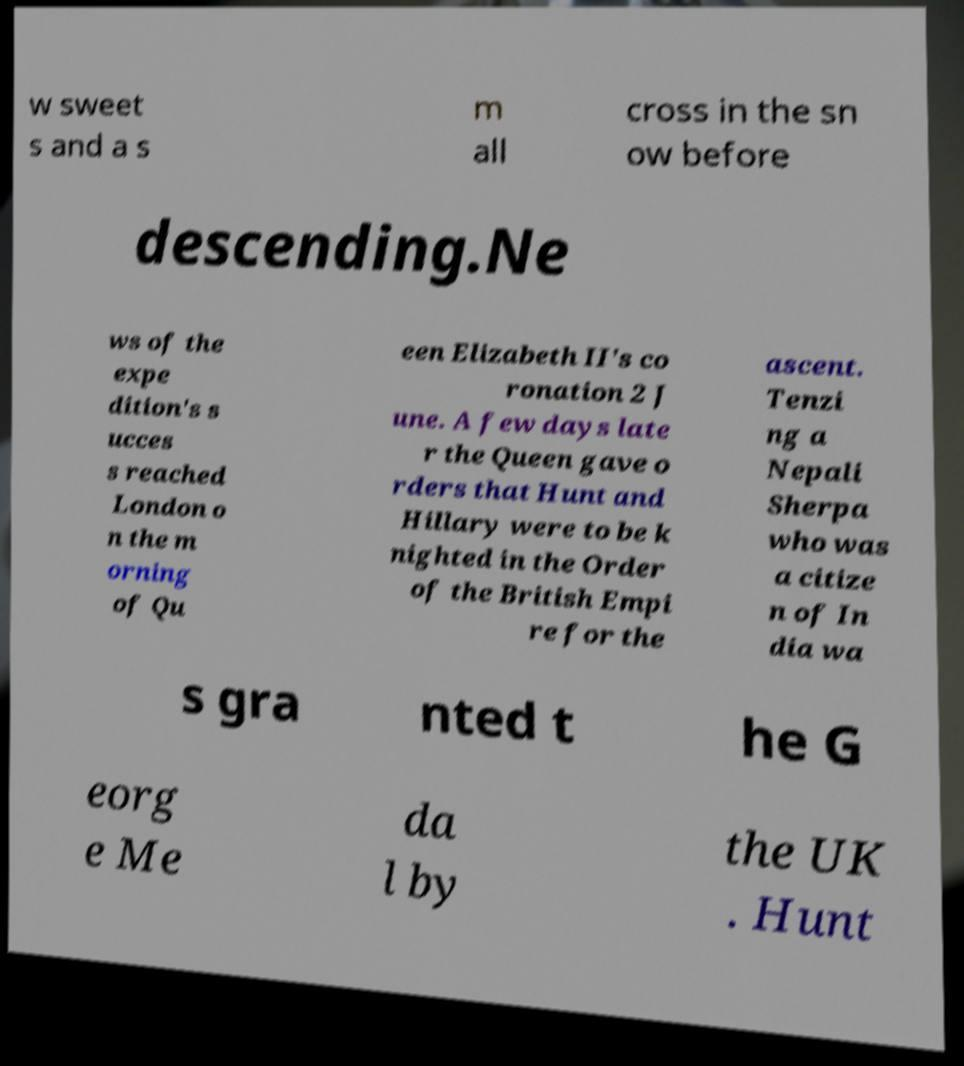Could you extract and type out the text from this image? w sweet s and a s m all cross in the sn ow before descending.Ne ws of the expe dition's s ucces s reached London o n the m orning of Qu een Elizabeth II's co ronation 2 J une. A few days late r the Queen gave o rders that Hunt and Hillary were to be k nighted in the Order of the British Empi re for the ascent. Tenzi ng a Nepali Sherpa who was a citize n of In dia wa s gra nted t he G eorg e Me da l by the UK . Hunt 